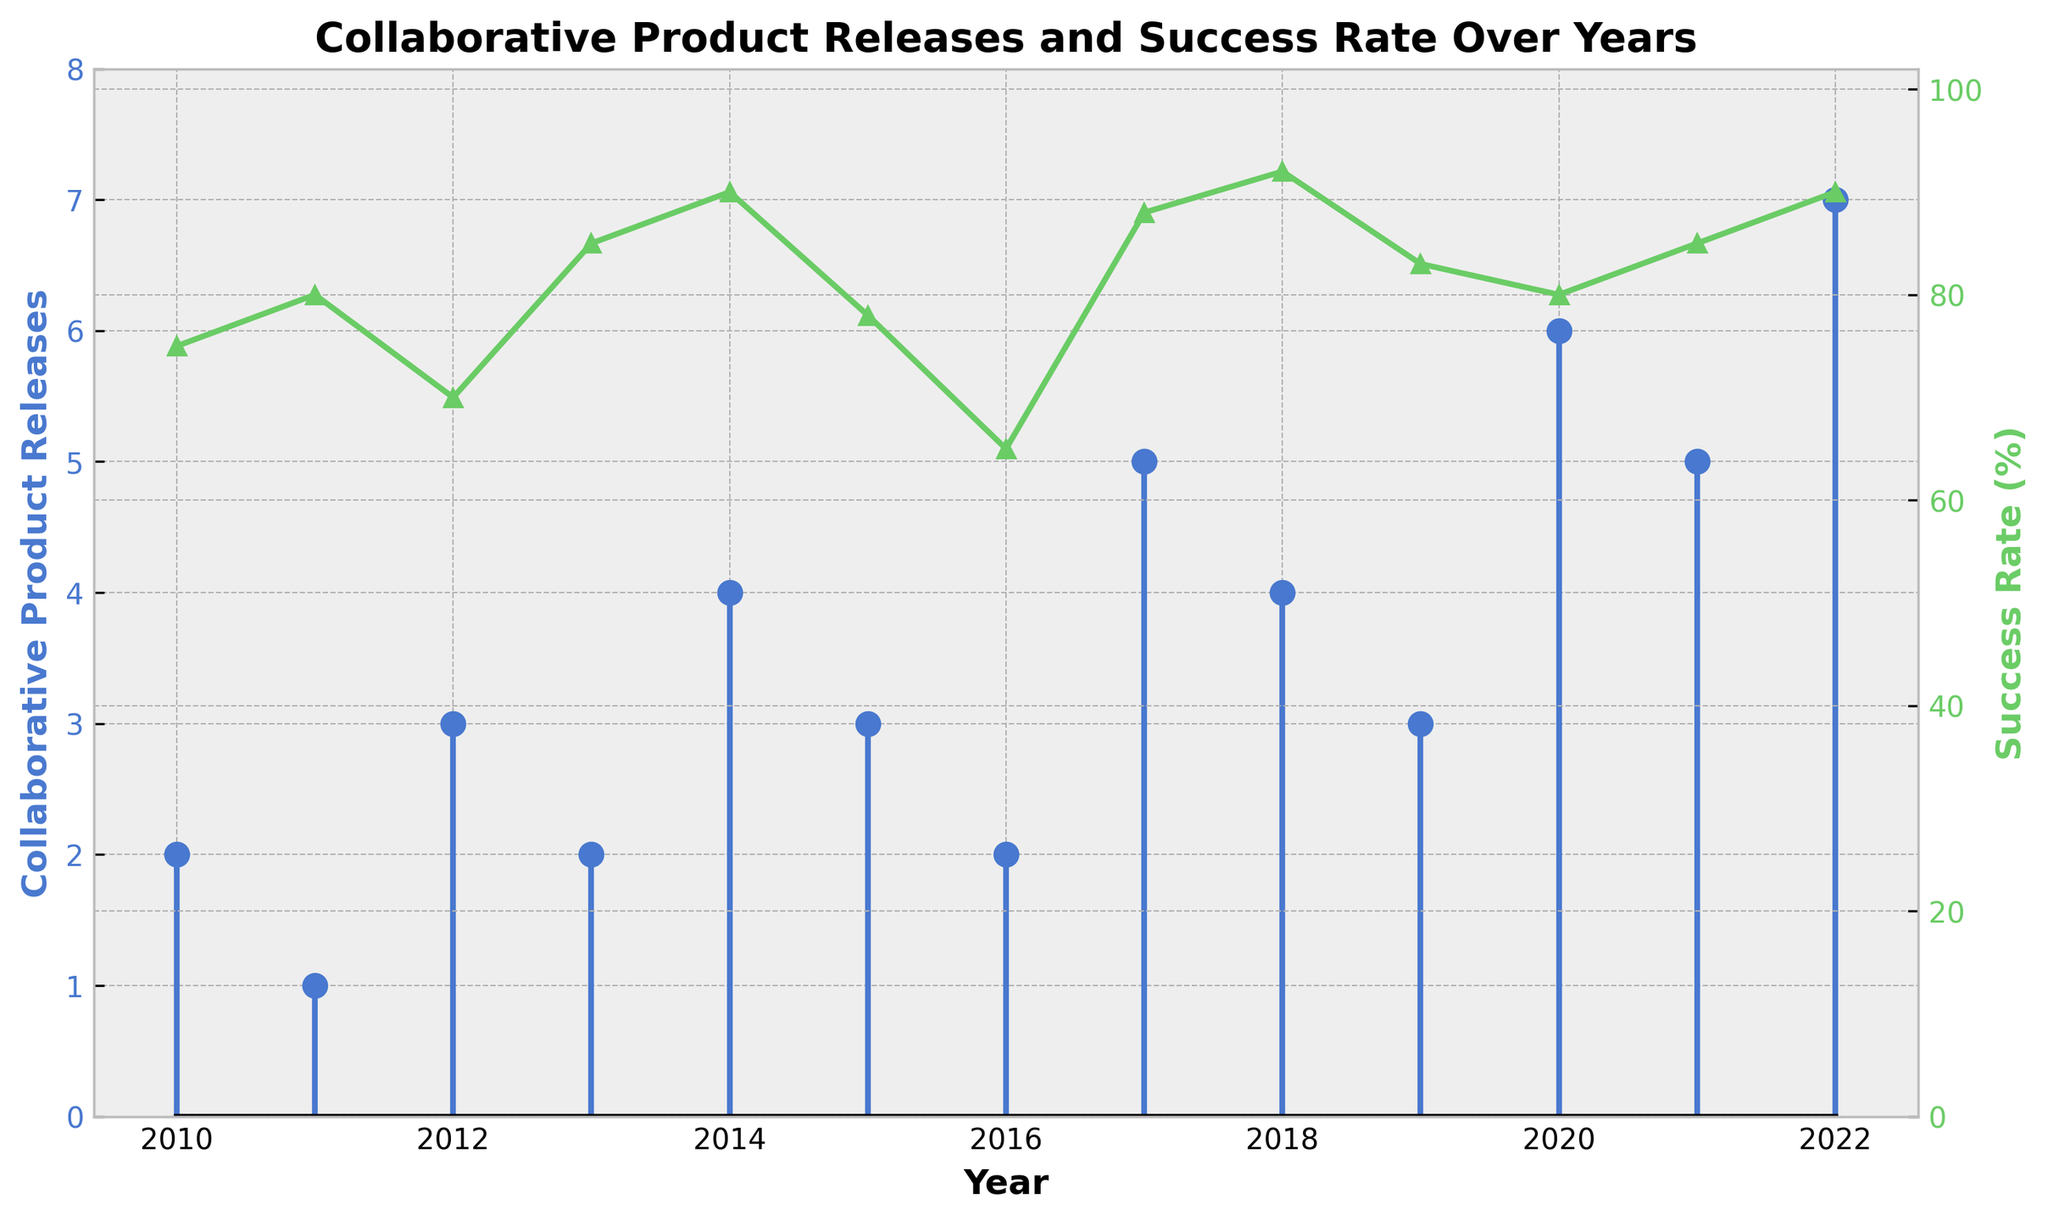What's the highest number of collaborative product releases in a single year? The largest stem is in 2022, which indicates that the highest number of collaborative product releases in a single year is 7.
Answer: 7 What's the lowest success rate recorded in the given years? The smallest data points on the secondary y-axis plot show the success rate in 2016, which is at 65%.
Answer: 65% How many collaborative product releases were there altogether from 2010 to 2022? Sum the values on the stem plot for each year: 2 + 1 + 3 + 2 + 4 + 3 + 2 + 5 + 4 + 3 + 6 + 5 + 7 = 47
Answer: 47 Which year had the highest success rate, and what was it? The line plot secondary y-axis peak is at 2018 with a rate of 92%.
Answer: 2018, 92% How does the number of collaborative product releases in 2017 compare to 2011? The stem plot for 2017 shows 5 releases, while 2011 shows 1 release, thus 2017 has 4 more releases than 2011.
Answer: 4 more In which years did the number of collaborative product releases consistently increase compared to the previous year? Analyze the increases year by year from the stem plots: 2012 (2 -> 3), 2014 (2 -> 4), 2017 (2 -> 5), 2019 (4 -> 3 -> 6), and 2022 (6 -> 7). Exceptions are years where a decrease follows an increase. Highlight the consistent increases: 2014, 2017, 2022.
Answer: 2014, 2017, 2022 What is the average success rate from 2010 to 2022? Sum success rates: (75 + 80 + 70 + 85 + 90 + 78 + 65 + 88 + 92 + 83 + 80 + 85 + 90) = 1081. Then, divide by 13 years: 1081 / 13 ≈ 83.2%.
Answer: 83.2% Between 2010 and 2015, which year had the highest number of collaborative product releases? Check individual stem values from 2010 to 2015: 2010 (2), 2011 (1), 2012 (3), 2013 (2), 2014 (4), 2015 (3). The highest value is 4 in 2014.
Answer: 2014 Compare the success rates between 2018 and 2020. Which year had a higher rate and by how much? Success rates: 2018 (92%), 2020 (80%). The rate in 2018 is higher by 92% - 80% = 12%.
Answer: 2018, 12% How did the success rate change from 2012 to 2013, and was this accompanied by a change in the number of product releases? Success rates show an increase from 70% (2012) to 85% (2013), a change of +15%. The number of releases stayed the same at 2.
Answer: Increase, 15%, no change in releases 